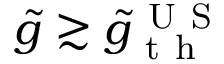Convert formula to latex. <formula><loc_0><loc_0><loc_500><loc_500>\tilde { g } \gtrsim \tilde { g } _ { t h } ^ { U S }</formula> 